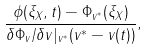<formula> <loc_0><loc_0><loc_500><loc_500>\frac { \phi ( \xi _ { X } , t ) - \Phi _ { v ^ { * } } ( \xi _ { X } ) } { \delta \Phi _ { v } / \delta v | _ { v ^ { * } } ( v ^ { * } - v ( t ) ) } ,</formula> 